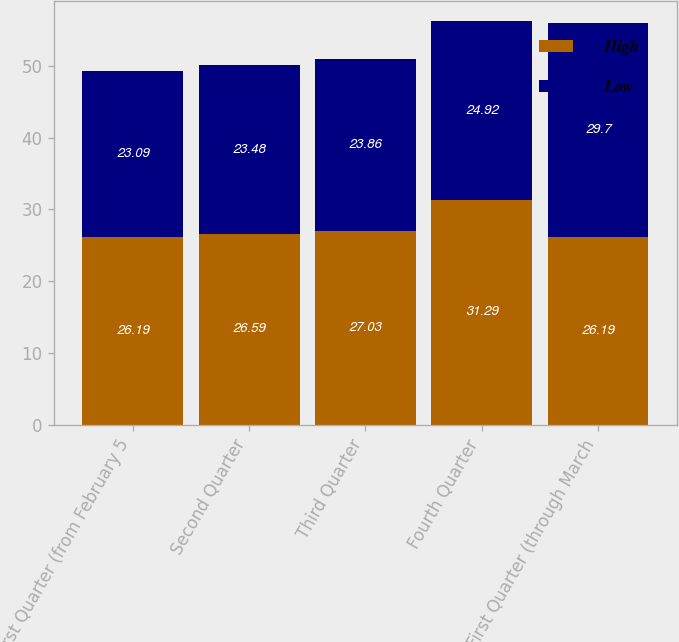Convert chart to OTSL. <chart><loc_0><loc_0><loc_500><loc_500><stacked_bar_chart><ecel><fcel>First Quarter (from February 5<fcel>Second Quarter<fcel>Third Quarter<fcel>Fourth Quarter<fcel>First Quarter (through March<nl><fcel>High<fcel>26.19<fcel>26.59<fcel>27.03<fcel>31.29<fcel>26.19<nl><fcel>Low<fcel>23.09<fcel>23.48<fcel>23.86<fcel>24.92<fcel>29.7<nl></chart> 